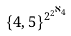Convert formula to latex. <formula><loc_0><loc_0><loc_500><loc_500>\{ 4 , 5 \} ^ { 2 ^ { 2 ^ { \aleph _ { 4 } } } }</formula> 